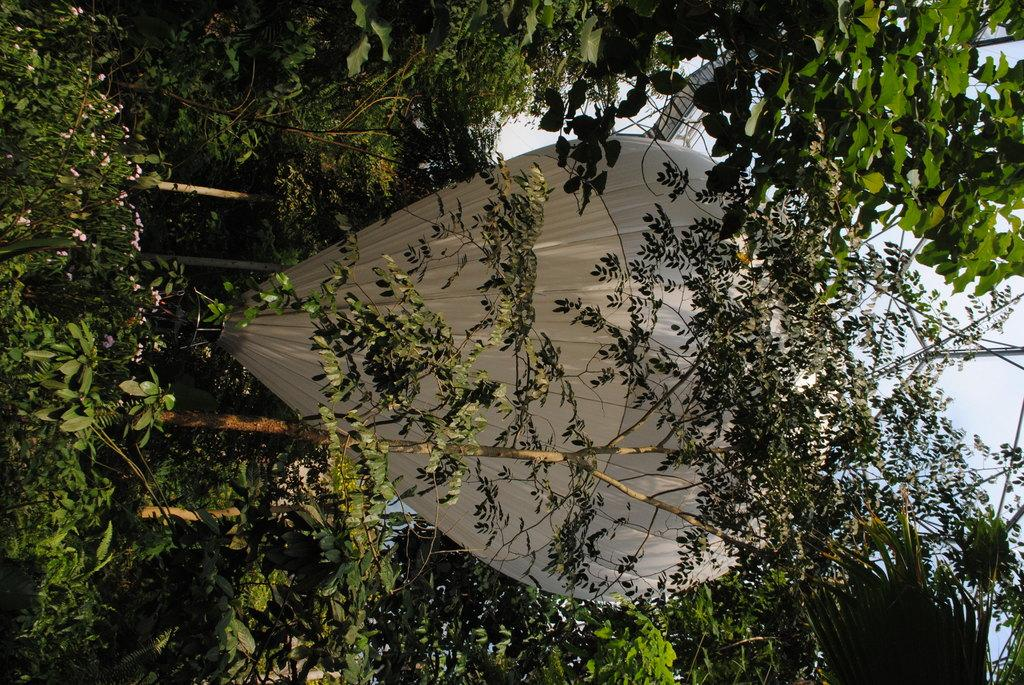What type of vegetation can be seen in the image? There are plants, flowers, and trees in the image. What activity is taking place in the image? Paragliding is visible in the image. What is visible in the background of the image? The sky is visible in the background of the image. What type of brass instrument is being played in the image? There is no brass instrument present in the image; it features plants, flowers, trees, paragliding, and the sky. What type of lock is securing the paraglider in the image? There is no lock present in the image; the paraglider is visible in the sky without any visible lock. 